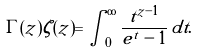<formula> <loc_0><loc_0><loc_500><loc_500>\Gamma ( z ) \zeta ( z ) = \int _ { 0 } ^ { \infty } \frac { t ^ { z - 1 } } { e ^ { t } - 1 } \, d t .</formula> 